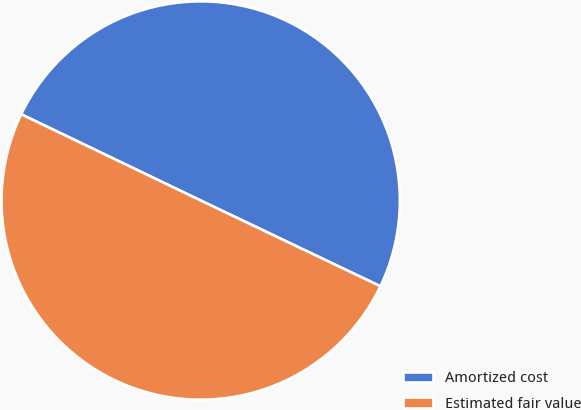<chart> <loc_0><loc_0><loc_500><loc_500><pie_chart><fcel>Amortized cost<fcel>Estimated fair value<nl><fcel>49.96%<fcel>50.04%<nl></chart> 